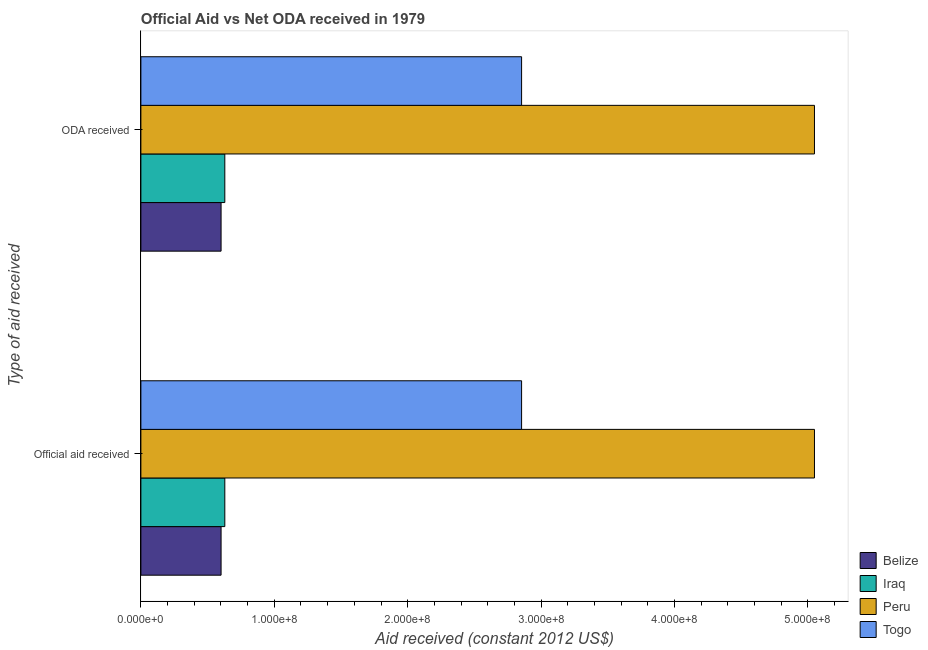How many groups of bars are there?
Give a very brief answer. 2. Are the number of bars per tick equal to the number of legend labels?
Offer a very short reply. Yes. What is the label of the 1st group of bars from the top?
Offer a very short reply. ODA received. What is the official aid received in Togo?
Make the answer very short. 2.85e+08. Across all countries, what is the maximum official aid received?
Your answer should be compact. 5.05e+08. Across all countries, what is the minimum official aid received?
Provide a succinct answer. 6.01e+07. In which country was the official aid received minimum?
Offer a very short reply. Belize. What is the total oda received in the graph?
Your response must be concise. 9.13e+08. What is the difference between the official aid received in Iraq and that in Belize?
Provide a short and direct response. 2.80e+06. What is the difference between the oda received in Iraq and the official aid received in Belize?
Your response must be concise. 2.80e+06. What is the average official aid received per country?
Your response must be concise. 2.28e+08. In how many countries, is the official aid received greater than 300000000 US$?
Keep it short and to the point. 1. What is the ratio of the official aid received in Togo to that in Iraq?
Provide a short and direct response. 4.54. Is the official aid received in Togo less than that in Iraq?
Ensure brevity in your answer.  No. What does the 1st bar from the top in Official aid received represents?
Ensure brevity in your answer.  Togo. What does the 3rd bar from the bottom in ODA received represents?
Your answer should be compact. Peru. Are all the bars in the graph horizontal?
Make the answer very short. Yes. How many countries are there in the graph?
Your answer should be very brief. 4. Are the values on the major ticks of X-axis written in scientific E-notation?
Make the answer very short. Yes. Does the graph contain any zero values?
Your response must be concise. No. Does the graph contain grids?
Your answer should be compact. No. Where does the legend appear in the graph?
Give a very brief answer. Bottom right. What is the title of the graph?
Your response must be concise. Official Aid vs Net ODA received in 1979 . Does "Vietnam" appear as one of the legend labels in the graph?
Offer a very short reply. No. What is the label or title of the X-axis?
Provide a succinct answer. Aid received (constant 2012 US$). What is the label or title of the Y-axis?
Offer a terse response. Type of aid received. What is the Aid received (constant 2012 US$) of Belize in Official aid received?
Offer a very short reply. 6.01e+07. What is the Aid received (constant 2012 US$) in Iraq in Official aid received?
Offer a terse response. 6.29e+07. What is the Aid received (constant 2012 US$) in Peru in Official aid received?
Your answer should be very brief. 5.05e+08. What is the Aid received (constant 2012 US$) in Togo in Official aid received?
Offer a terse response. 2.85e+08. What is the Aid received (constant 2012 US$) in Belize in ODA received?
Provide a succinct answer. 6.01e+07. What is the Aid received (constant 2012 US$) in Iraq in ODA received?
Your answer should be compact. 6.29e+07. What is the Aid received (constant 2012 US$) in Peru in ODA received?
Keep it short and to the point. 5.05e+08. What is the Aid received (constant 2012 US$) of Togo in ODA received?
Offer a terse response. 2.85e+08. Across all Type of aid received, what is the maximum Aid received (constant 2012 US$) in Belize?
Provide a succinct answer. 6.01e+07. Across all Type of aid received, what is the maximum Aid received (constant 2012 US$) in Iraq?
Keep it short and to the point. 6.29e+07. Across all Type of aid received, what is the maximum Aid received (constant 2012 US$) in Peru?
Your response must be concise. 5.05e+08. Across all Type of aid received, what is the maximum Aid received (constant 2012 US$) of Togo?
Ensure brevity in your answer.  2.85e+08. Across all Type of aid received, what is the minimum Aid received (constant 2012 US$) of Belize?
Provide a short and direct response. 6.01e+07. Across all Type of aid received, what is the minimum Aid received (constant 2012 US$) of Iraq?
Provide a short and direct response. 6.29e+07. Across all Type of aid received, what is the minimum Aid received (constant 2012 US$) of Peru?
Ensure brevity in your answer.  5.05e+08. Across all Type of aid received, what is the minimum Aid received (constant 2012 US$) in Togo?
Offer a terse response. 2.85e+08. What is the total Aid received (constant 2012 US$) of Belize in the graph?
Provide a short and direct response. 1.20e+08. What is the total Aid received (constant 2012 US$) of Iraq in the graph?
Make the answer very short. 1.26e+08. What is the total Aid received (constant 2012 US$) of Peru in the graph?
Provide a succinct answer. 1.01e+09. What is the total Aid received (constant 2012 US$) of Togo in the graph?
Your answer should be very brief. 5.71e+08. What is the difference between the Aid received (constant 2012 US$) in Belize in Official aid received and that in ODA received?
Ensure brevity in your answer.  0. What is the difference between the Aid received (constant 2012 US$) in Iraq in Official aid received and that in ODA received?
Give a very brief answer. 0. What is the difference between the Aid received (constant 2012 US$) of Peru in Official aid received and that in ODA received?
Your answer should be compact. 0. What is the difference between the Aid received (constant 2012 US$) of Togo in Official aid received and that in ODA received?
Offer a very short reply. 0. What is the difference between the Aid received (constant 2012 US$) of Belize in Official aid received and the Aid received (constant 2012 US$) of Iraq in ODA received?
Ensure brevity in your answer.  -2.80e+06. What is the difference between the Aid received (constant 2012 US$) of Belize in Official aid received and the Aid received (constant 2012 US$) of Peru in ODA received?
Provide a succinct answer. -4.45e+08. What is the difference between the Aid received (constant 2012 US$) in Belize in Official aid received and the Aid received (constant 2012 US$) in Togo in ODA received?
Provide a succinct answer. -2.25e+08. What is the difference between the Aid received (constant 2012 US$) in Iraq in Official aid received and the Aid received (constant 2012 US$) in Peru in ODA received?
Your response must be concise. -4.42e+08. What is the difference between the Aid received (constant 2012 US$) in Iraq in Official aid received and the Aid received (constant 2012 US$) in Togo in ODA received?
Provide a succinct answer. -2.22e+08. What is the difference between the Aid received (constant 2012 US$) of Peru in Official aid received and the Aid received (constant 2012 US$) of Togo in ODA received?
Offer a terse response. 2.20e+08. What is the average Aid received (constant 2012 US$) of Belize per Type of aid received?
Provide a short and direct response. 6.01e+07. What is the average Aid received (constant 2012 US$) in Iraq per Type of aid received?
Ensure brevity in your answer.  6.29e+07. What is the average Aid received (constant 2012 US$) of Peru per Type of aid received?
Offer a very short reply. 5.05e+08. What is the average Aid received (constant 2012 US$) of Togo per Type of aid received?
Give a very brief answer. 2.85e+08. What is the difference between the Aid received (constant 2012 US$) of Belize and Aid received (constant 2012 US$) of Iraq in Official aid received?
Provide a succinct answer. -2.80e+06. What is the difference between the Aid received (constant 2012 US$) in Belize and Aid received (constant 2012 US$) in Peru in Official aid received?
Keep it short and to the point. -4.45e+08. What is the difference between the Aid received (constant 2012 US$) of Belize and Aid received (constant 2012 US$) of Togo in Official aid received?
Your answer should be very brief. -2.25e+08. What is the difference between the Aid received (constant 2012 US$) in Iraq and Aid received (constant 2012 US$) in Peru in Official aid received?
Your response must be concise. -4.42e+08. What is the difference between the Aid received (constant 2012 US$) of Iraq and Aid received (constant 2012 US$) of Togo in Official aid received?
Provide a short and direct response. -2.22e+08. What is the difference between the Aid received (constant 2012 US$) of Peru and Aid received (constant 2012 US$) of Togo in Official aid received?
Offer a terse response. 2.20e+08. What is the difference between the Aid received (constant 2012 US$) in Belize and Aid received (constant 2012 US$) in Iraq in ODA received?
Your answer should be very brief. -2.80e+06. What is the difference between the Aid received (constant 2012 US$) of Belize and Aid received (constant 2012 US$) of Peru in ODA received?
Your response must be concise. -4.45e+08. What is the difference between the Aid received (constant 2012 US$) of Belize and Aid received (constant 2012 US$) of Togo in ODA received?
Your response must be concise. -2.25e+08. What is the difference between the Aid received (constant 2012 US$) of Iraq and Aid received (constant 2012 US$) of Peru in ODA received?
Keep it short and to the point. -4.42e+08. What is the difference between the Aid received (constant 2012 US$) of Iraq and Aid received (constant 2012 US$) of Togo in ODA received?
Provide a succinct answer. -2.22e+08. What is the difference between the Aid received (constant 2012 US$) in Peru and Aid received (constant 2012 US$) in Togo in ODA received?
Make the answer very short. 2.20e+08. What is the ratio of the Aid received (constant 2012 US$) of Belize in Official aid received to that in ODA received?
Keep it short and to the point. 1. What is the difference between the highest and the second highest Aid received (constant 2012 US$) in Belize?
Offer a terse response. 0. What is the difference between the highest and the lowest Aid received (constant 2012 US$) in Iraq?
Offer a very short reply. 0. 